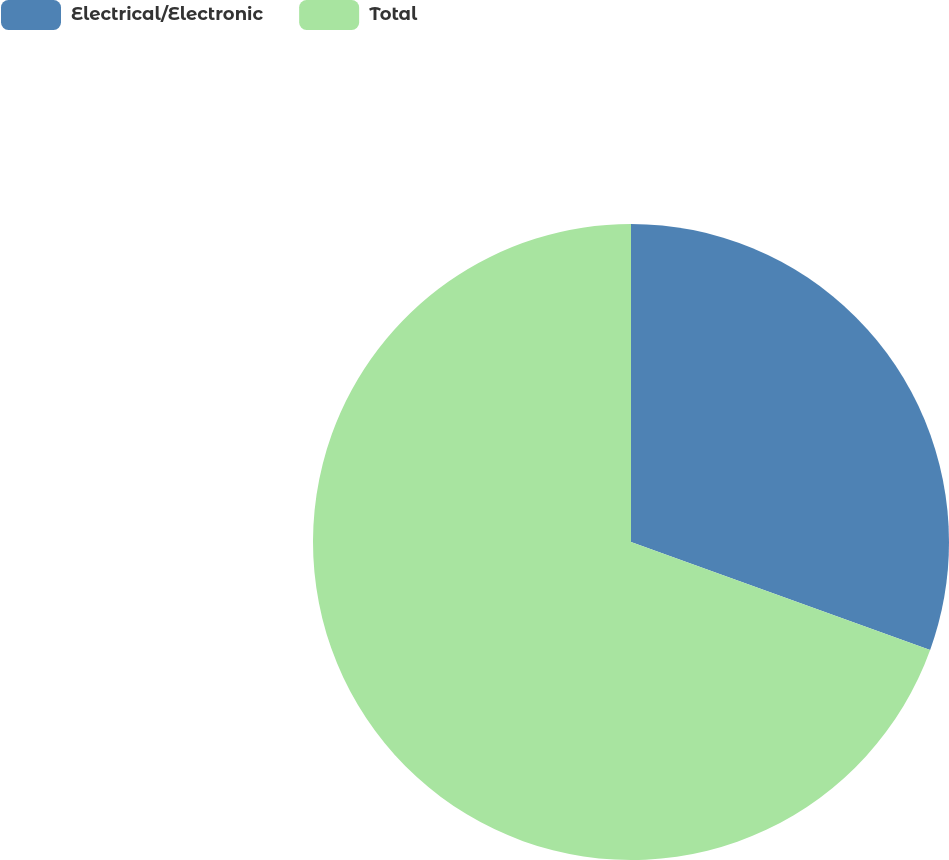<chart> <loc_0><loc_0><loc_500><loc_500><pie_chart><fcel>Electrical/Electronic<fcel>Total<nl><fcel>30.51%<fcel>69.49%<nl></chart> 